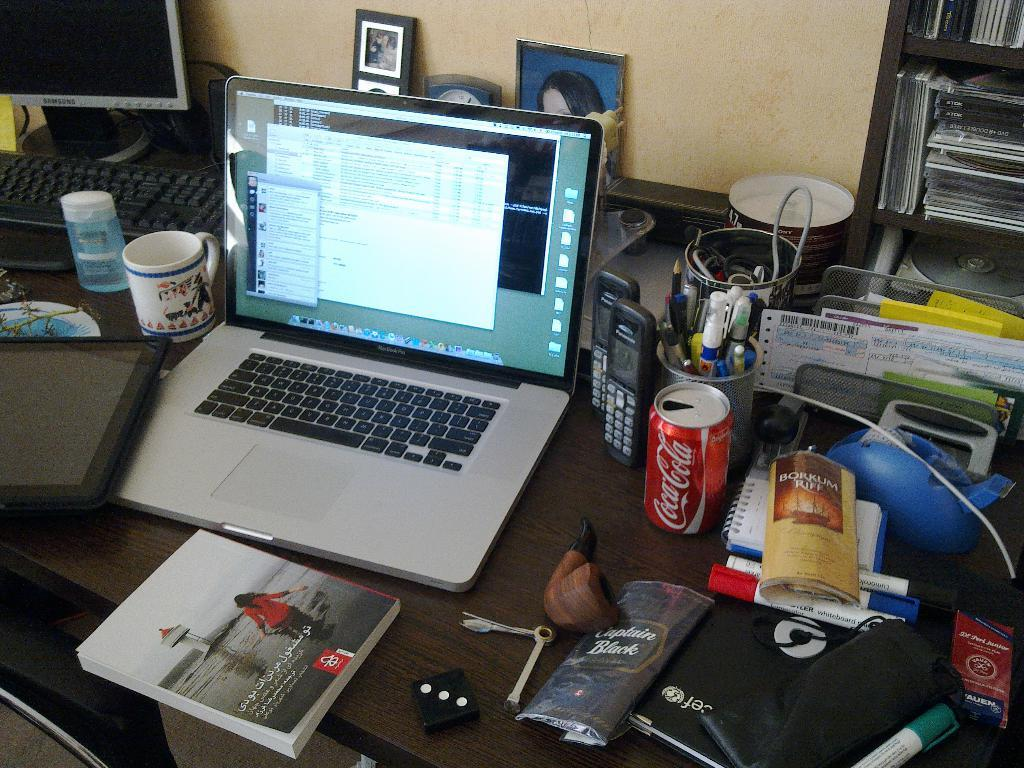What electronic device is visible in the image? There is a laptop in the image. What other electronic device might be present in the image? There is a system (possibly a computer) in the image. What can be seen on the table in the image? There are objects on the table. Where are the books located in the image? There is a cupboard of books to the right of the table. What type of plastic material is used to create the body of the laptop in the image? The image does not provide information about the materials used to create the laptop, so it cannot be determined from the image. 